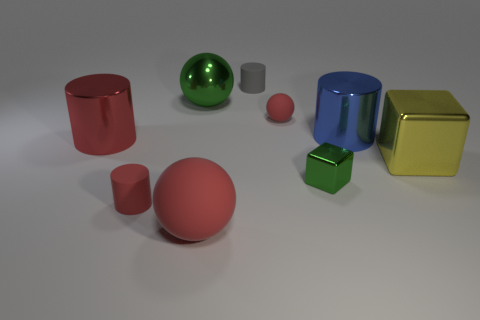Subtract all small gray cylinders. How many cylinders are left? 3 Subtract all gray cylinders. How many cylinders are left? 3 Subtract all cylinders. How many objects are left? 5 Subtract all blue spheres. How many yellow blocks are left? 1 Subtract 2 spheres. How many spheres are left? 1 Subtract all blue balls. Subtract all brown cylinders. How many balls are left? 3 Subtract all red rubber cylinders. Subtract all green blocks. How many objects are left? 7 Add 6 large metal spheres. How many large metal spheres are left? 7 Add 4 large yellow metallic things. How many large yellow metallic things exist? 5 Subtract 0 purple spheres. How many objects are left? 9 